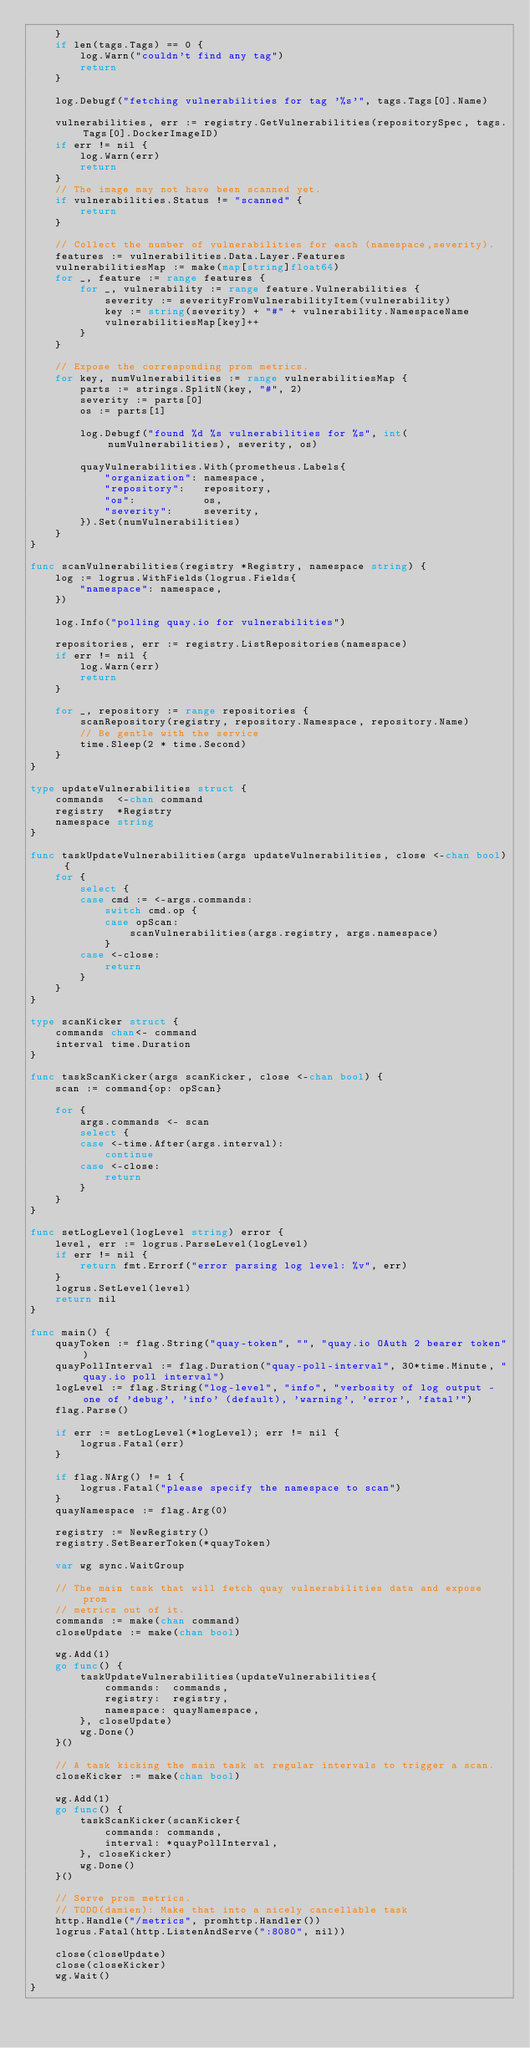<code> <loc_0><loc_0><loc_500><loc_500><_Go_>	}
	if len(tags.Tags) == 0 {
		log.Warn("couldn't find any tag")
		return
	}

	log.Debugf("fetching vulnerabilities for tag '%s'", tags.Tags[0].Name)

	vulnerabilities, err := registry.GetVulnerabilities(repositorySpec, tags.Tags[0].DockerImageID)
	if err != nil {
		log.Warn(err)
		return
	}
	// The image may not have been scanned yet.
	if vulnerabilities.Status != "scanned" {
		return
	}

	// Collect the number of vulnerabilities for each (namespace,severity).
	features := vulnerabilities.Data.Layer.Features
	vulnerabilitiesMap := make(map[string]float64)
	for _, feature := range features {
		for _, vulnerability := range feature.Vulnerabilities {
			severity := severityFromVulnerabilityItem(vulnerability)
			key := string(severity) + "#" + vulnerability.NamespaceName
			vulnerabilitiesMap[key]++
		}
	}

	// Expose the corresponding prom metrics.
	for key, numVulnerabilities := range vulnerabilitiesMap {
		parts := strings.SplitN(key, "#", 2)
		severity := parts[0]
		os := parts[1]

		log.Debugf("found %d %s vulnerabilities for %s", int(numVulnerabilities), severity, os)

		quayVulnerabilities.With(prometheus.Labels{
			"organization": namespace,
			"repository":   repository,
			"os":           os,
			"severity":     severity,
		}).Set(numVulnerabilities)
	}
}

func scanVulnerabilities(registry *Registry, namespace string) {
	log := logrus.WithFields(logrus.Fields{
		"namespace": namespace,
	})

	log.Info("polling quay.io for vulnerabilities")

	repositories, err := registry.ListRepositories(namespace)
	if err != nil {
		log.Warn(err)
		return
	}

	for _, repository := range repositories {
		scanRepository(registry, repository.Namespace, repository.Name)
		// Be gentle with the service
		time.Sleep(2 * time.Second)
	}
}

type updateVulnerabilities struct {
	commands  <-chan command
	registry  *Registry
	namespace string
}

func taskUpdateVulnerabilities(args updateVulnerabilities, close <-chan bool) {
	for {
		select {
		case cmd := <-args.commands:
			switch cmd.op {
			case opScan:
				scanVulnerabilities(args.registry, args.namespace)
			}
		case <-close:
			return
		}
	}
}

type scanKicker struct {
	commands chan<- command
	interval time.Duration
}

func taskScanKicker(args scanKicker, close <-chan bool) {
	scan := command{op: opScan}

	for {
		args.commands <- scan
		select {
		case <-time.After(args.interval):
			continue
		case <-close:
			return
		}
	}
}

func setLogLevel(logLevel string) error {
	level, err := logrus.ParseLevel(logLevel)
	if err != nil {
		return fmt.Errorf("error parsing log level: %v", err)
	}
	logrus.SetLevel(level)
	return nil
}

func main() {
	quayToken := flag.String("quay-token", "", "quay.io OAuth 2 bearer token")
	quayPollInterval := flag.Duration("quay-poll-interval", 30*time.Minute, "quay.io poll interval")
	logLevel := flag.String("log-level", "info", "verbosity of log output - one of 'debug', 'info' (default), 'warning', 'error', 'fatal'")
	flag.Parse()

	if err := setLogLevel(*logLevel); err != nil {
		logrus.Fatal(err)
	}

	if flag.NArg() != 1 {
		logrus.Fatal("please specify the namespace to scan")
	}
	quayNamespace := flag.Arg(0)

	registry := NewRegistry()
	registry.SetBearerToken(*quayToken)

	var wg sync.WaitGroup

	// The main task that will fetch quay vulnerabilities data and expose prom
	// metrics out of it.
	commands := make(chan command)
	closeUpdate := make(chan bool)

	wg.Add(1)
	go func() {
		taskUpdateVulnerabilities(updateVulnerabilities{
			commands:  commands,
			registry:  registry,
			namespace: quayNamespace,
		}, closeUpdate)
		wg.Done()
	}()

	// A task kicking the main task at regular intervals to trigger a scan.
	closeKicker := make(chan bool)

	wg.Add(1)
	go func() {
		taskScanKicker(scanKicker{
			commands: commands,
			interval: *quayPollInterval,
		}, closeKicker)
		wg.Done()
	}()

	// Serve prom metrics.
	// TODO(damien): Make that into a nicely cancellable task
	http.Handle("/metrics", promhttp.Handler())
	logrus.Fatal(http.ListenAndServe(":8080", nil))

	close(closeUpdate)
	close(closeKicker)
	wg.Wait()
}
</code> 